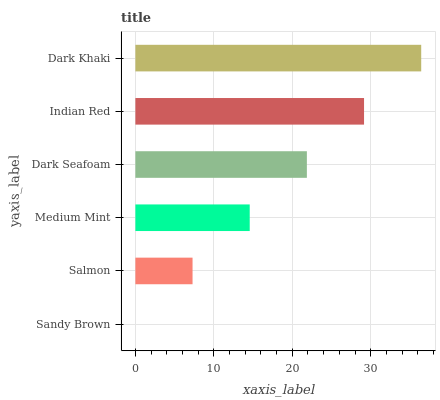Is Sandy Brown the minimum?
Answer yes or no. Yes. Is Dark Khaki the maximum?
Answer yes or no. Yes. Is Salmon the minimum?
Answer yes or no. No. Is Salmon the maximum?
Answer yes or no. No. Is Salmon greater than Sandy Brown?
Answer yes or no. Yes. Is Sandy Brown less than Salmon?
Answer yes or no. Yes. Is Sandy Brown greater than Salmon?
Answer yes or no. No. Is Salmon less than Sandy Brown?
Answer yes or no. No. Is Dark Seafoam the high median?
Answer yes or no. Yes. Is Medium Mint the low median?
Answer yes or no. Yes. Is Medium Mint the high median?
Answer yes or no. No. Is Sandy Brown the low median?
Answer yes or no. No. 